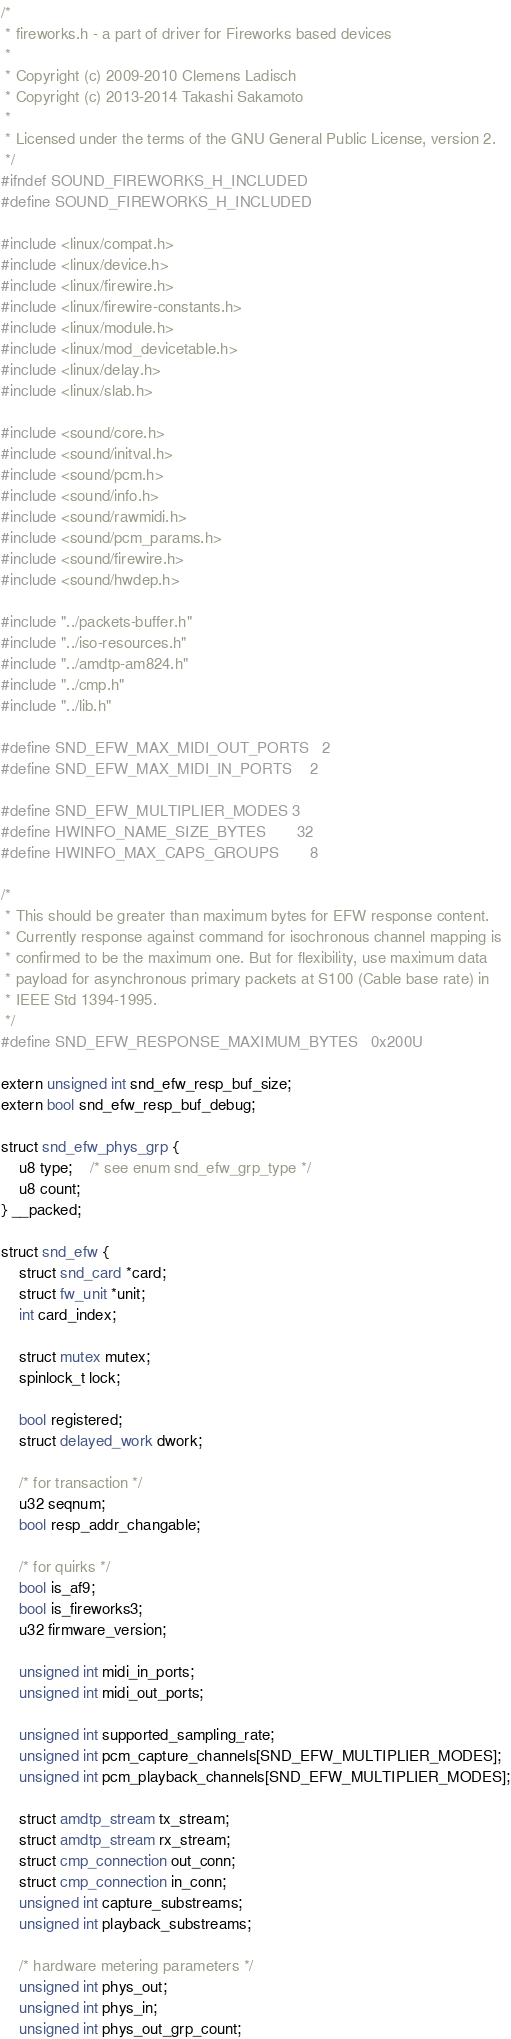Convert code to text. <code><loc_0><loc_0><loc_500><loc_500><_C_>/*
 * fireworks.h - a part of driver for Fireworks based devices
 *
 * Copyright (c) 2009-2010 Clemens Ladisch
 * Copyright (c) 2013-2014 Takashi Sakamoto
 *
 * Licensed under the terms of the GNU General Public License, version 2.
 */
#ifndef SOUND_FIREWORKS_H_INCLUDED
#define SOUND_FIREWORKS_H_INCLUDED

#include <linux/compat.h>
#include <linux/device.h>
#include <linux/firewire.h>
#include <linux/firewire-constants.h>
#include <linux/module.h>
#include <linux/mod_devicetable.h>
#include <linux/delay.h>
#include <linux/slab.h>

#include <sound/core.h>
#include <sound/initval.h>
#include <sound/pcm.h>
#include <sound/info.h>
#include <sound/rawmidi.h>
#include <sound/pcm_params.h>
#include <sound/firewire.h>
#include <sound/hwdep.h>

#include "../packets-buffer.h"
#include "../iso-resources.h"
#include "../amdtp-am824.h"
#include "../cmp.h"
#include "../lib.h"

#define SND_EFW_MAX_MIDI_OUT_PORTS	2
#define SND_EFW_MAX_MIDI_IN_PORTS	2

#define SND_EFW_MULTIPLIER_MODES	3
#define HWINFO_NAME_SIZE_BYTES		32
#define HWINFO_MAX_CAPS_GROUPS		8

/*
 * This should be greater than maximum bytes for EFW response content.
 * Currently response against command for isochronous channel mapping is
 * confirmed to be the maximum one. But for flexibility, use maximum data
 * payload for asynchronous primary packets at S100 (Cable base rate) in
 * IEEE Std 1394-1995.
 */
#define SND_EFW_RESPONSE_MAXIMUM_BYTES	0x200U

extern unsigned int snd_efw_resp_buf_size;
extern bool snd_efw_resp_buf_debug;

struct snd_efw_phys_grp {
	u8 type;	/* see enum snd_efw_grp_type */
	u8 count;
} __packed;

struct snd_efw {
	struct snd_card *card;
	struct fw_unit *unit;
	int card_index;

	struct mutex mutex;
	spinlock_t lock;

	bool registered;
	struct delayed_work dwork;

	/* for transaction */
	u32 seqnum;
	bool resp_addr_changable;

	/* for quirks */
	bool is_af9;
	bool is_fireworks3;
	u32 firmware_version;

	unsigned int midi_in_ports;
	unsigned int midi_out_ports;

	unsigned int supported_sampling_rate;
	unsigned int pcm_capture_channels[SND_EFW_MULTIPLIER_MODES];
	unsigned int pcm_playback_channels[SND_EFW_MULTIPLIER_MODES];

	struct amdtp_stream tx_stream;
	struct amdtp_stream rx_stream;
	struct cmp_connection out_conn;
	struct cmp_connection in_conn;
	unsigned int capture_substreams;
	unsigned int playback_substreams;

	/* hardware metering parameters */
	unsigned int phys_out;
	unsigned int phys_in;
	unsigned int phys_out_grp_count;</code> 